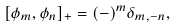<formula> <loc_0><loc_0><loc_500><loc_500>[ \phi _ { m } , \phi _ { n } ] _ { + } = ( - ) ^ { m } \delta _ { m , - n } ,</formula> 